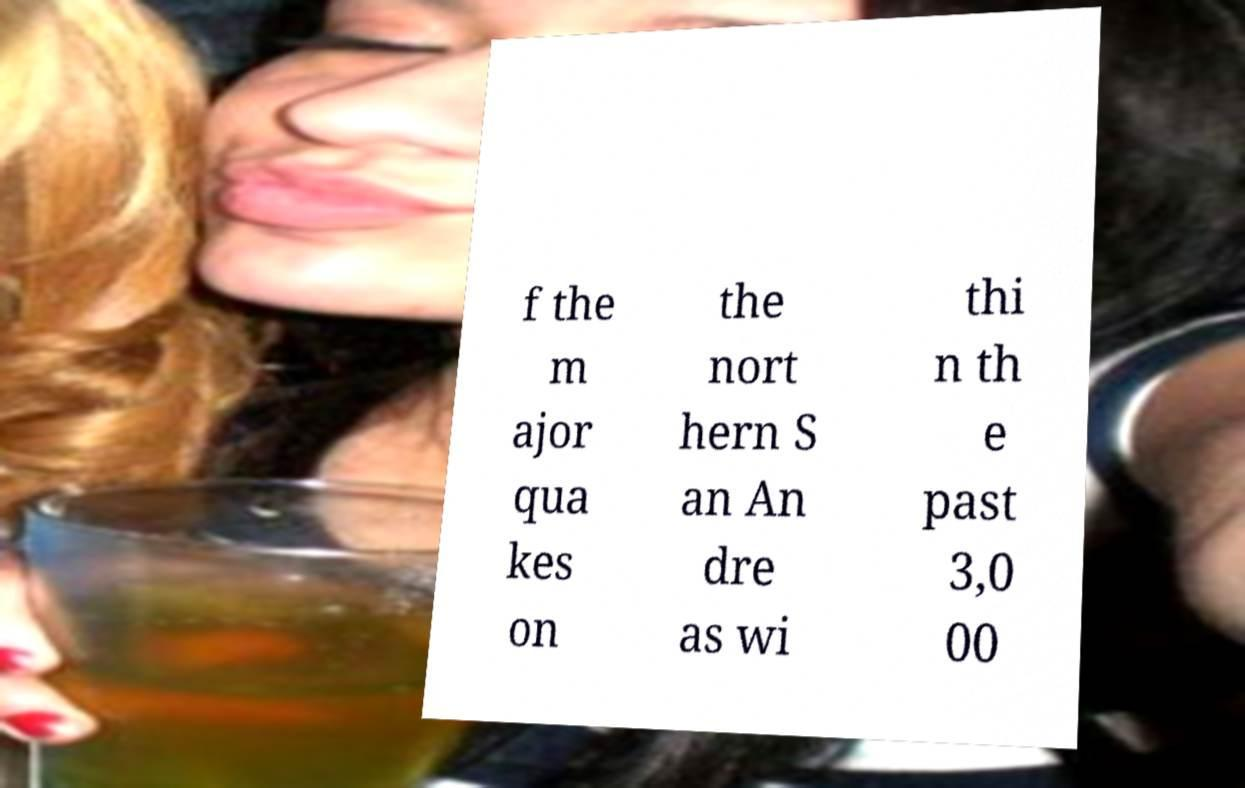For documentation purposes, I need the text within this image transcribed. Could you provide that? f the m ajor qua kes on the nort hern S an An dre as wi thi n th e past 3,0 00 